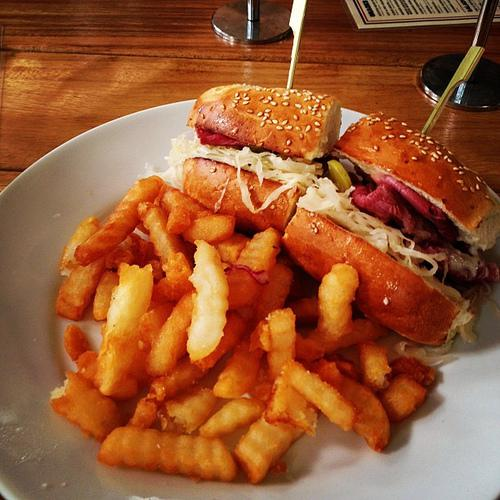Question: what is in the photo?
Choices:
A. A house.
B. A door.
C. Food.
D. A car.
Answer with the letter. Answer: C Question: who is in the photo?
Choices:
A. A mother.
B. A kid.
C. A student.
D. Nobody.
Answer with the letter. Answer: D 